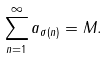<formula> <loc_0><loc_0><loc_500><loc_500>\sum _ { n = 1 } ^ { \infty } a _ { \sigma ( n ) } = M .</formula> 